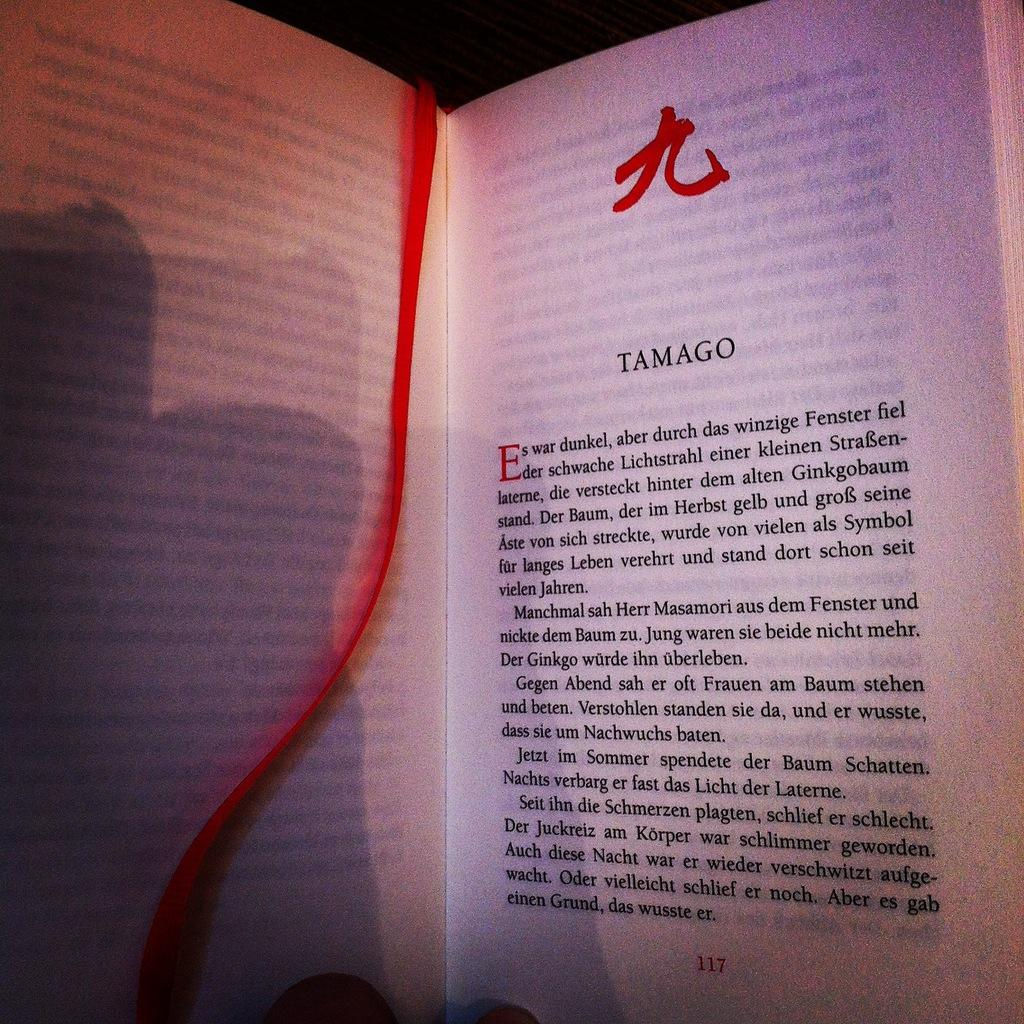<image>
Create a compact narrative representing the image presented. A book is open to page 117 and has a red ribbon bookmark. 